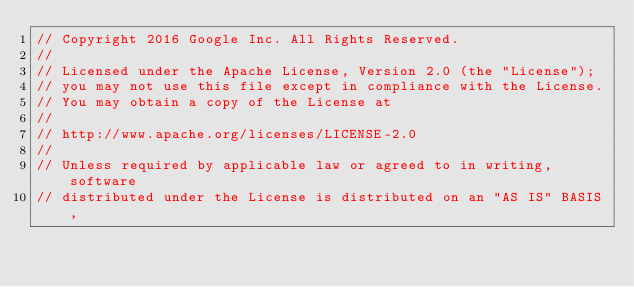Convert code to text. <code><loc_0><loc_0><loc_500><loc_500><_Java_>// Copyright 2016 Google Inc. All Rights Reserved.
//
// Licensed under the Apache License, Version 2.0 (the "License");
// you may not use this file except in compliance with the License.
// You may obtain a copy of the License at
//
// http://www.apache.org/licenses/LICENSE-2.0
//
// Unless required by applicable law or agreed to in writing, software
// distributed under the License is distributed on an "AS IS" BASIS,</code> 